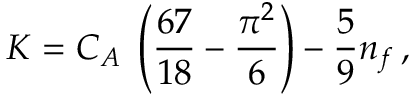<formula> <loc_0><loc_0><loc_500><loc_500>K = C _ { A } \, \left ( { \frac { 6 7 } { 1 8 } } - { \frac { \pi ^ { 2 } } { 6 } } \right ) - { \frac { 5 } { 9 } } n _ { f } \, ,</formula> 